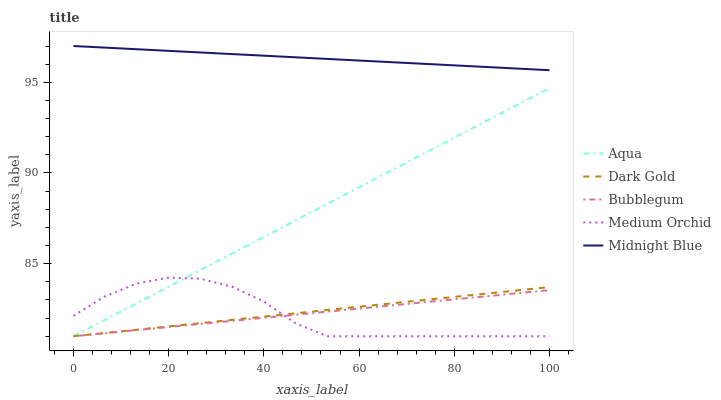Does Medium Orchid have the minimum area under the curve?
Answer yes or no. Yes. Does Midnight Blue have the maximum area under the curve?
Answer yes or no. Yes. Does Aqua have the minimum area under the curve?
Answer yes or no. No. Does Aqua have the maximum area under the curve?
Answer yes or no. No. Is Midnight Blue the smoothest?
Answer yes or no. Yes. Is Medium Orchid the roughest?
Answer yes or no. Yes. Is Aqua the smoothest?
Answer yes or no. No. Is Aqua the roughest?
Answer yes or no. No. Does Medium Orchid have the lowest value?
Answer yes or no. Yes. Does Midnight Blue have the lowest value?
Answer yes or no. No. Does Midnight Blue have the highest value?
Answer yes or no. Yes. Does Aqua have the highest value?
Answer yes or no. No. Is Bubblegum less than Midnight Blue?
Answer yes or no. Yes. Is Midnight Blue greater than Bubblegum?
Answer yes or no. Yes. Does Dark Gold intersect Medium Orchid?
Answer yes or no. Yes. Is Dark Gold less than Medium Orchid?
Answer yes or no. No. Is Dark Gold greater than Medium Orchid?
Answer yes or no. No. Does Bubblegum intersect Midnight Blue?
Answer yes or no. No. 